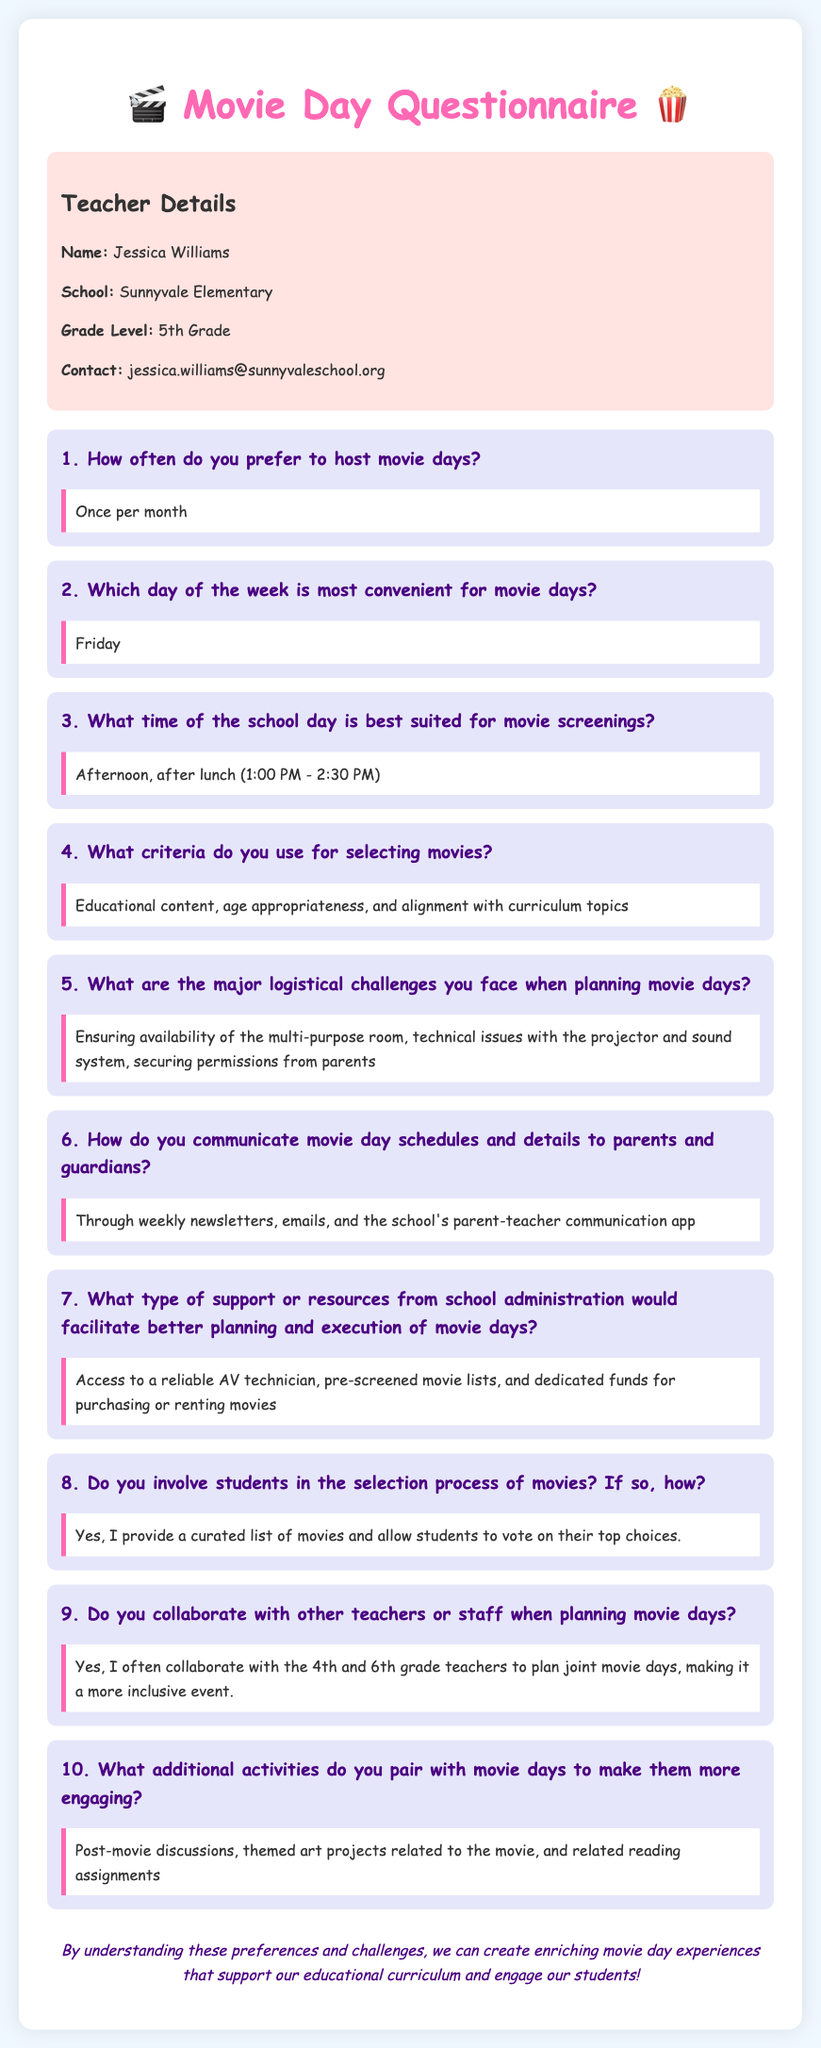What is the name of the teacher? The teacher's name is provided in the teacher details section of the document.
Answer: Jessica Williams How often does the teacher prefer to host movie days? The response indicates the frequency of hosting movie days as given in the questionnaire.
Answer: Once per month What day of the week is most convenient for movie days? The most convenient day for movie days is specified in the questionnaire response.
Answer: Friday What criteria does the teacher use for selecting movies? The criteria for selecting movies can be found in the response to the relevant question in the document.
Answer: Educational content, age appropriateness, and alignment with curriculum topics What logistical challenge is mentioned regarding movie days? The response lists specific logistical challenges faced when planning movie days.
Answer: Ensuring availability of the multi-purpose room In what time frame does the teacher prefer to schedule movie screenings? The preferred timing for movie screenings is noted clearly in the questionnaire response.
Answer: Afternoon, after lunch (1:00 PM - 2:30 PM) How does the teacher communicate movie day details to parents? The methods for communicating details about movie days are provided in the questionnaire response.
Answer: Through weekly newsletters, emails, and the school's parent-teacher communication app Does the teacher involve students in the movie selection process? The response indicates whether or not students participate in the selection process.
Answer: Yes What additional activities are paired with movie days? The response lists additional activities that complement movie days according to the teacher's plan.
Answer: Post-movie discussions, themed art projects related to the movie, and related reading assignments 